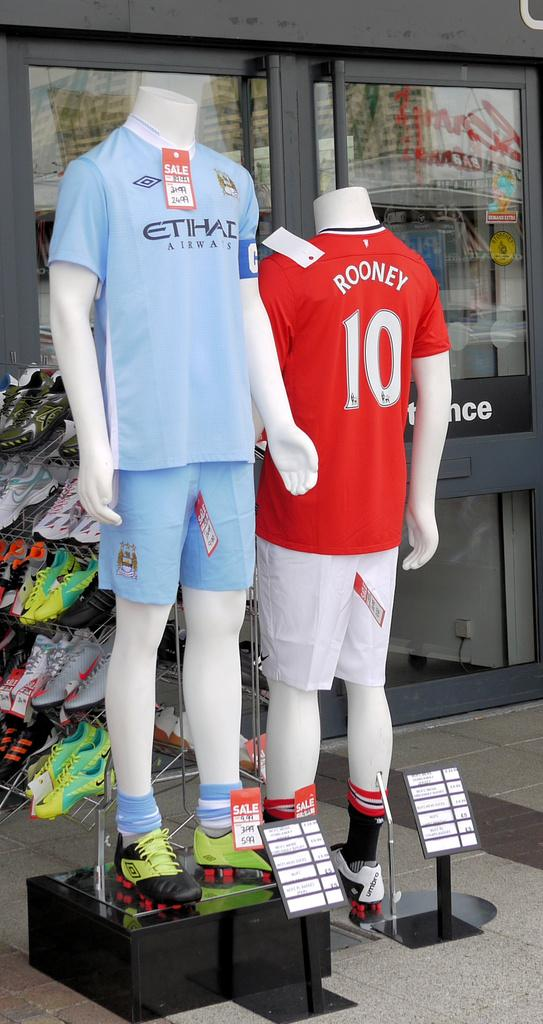Provide a one-sentence caption for the provided image. Two mannequins are outside of a store and one is wearing a shirt with rooney written on it. 